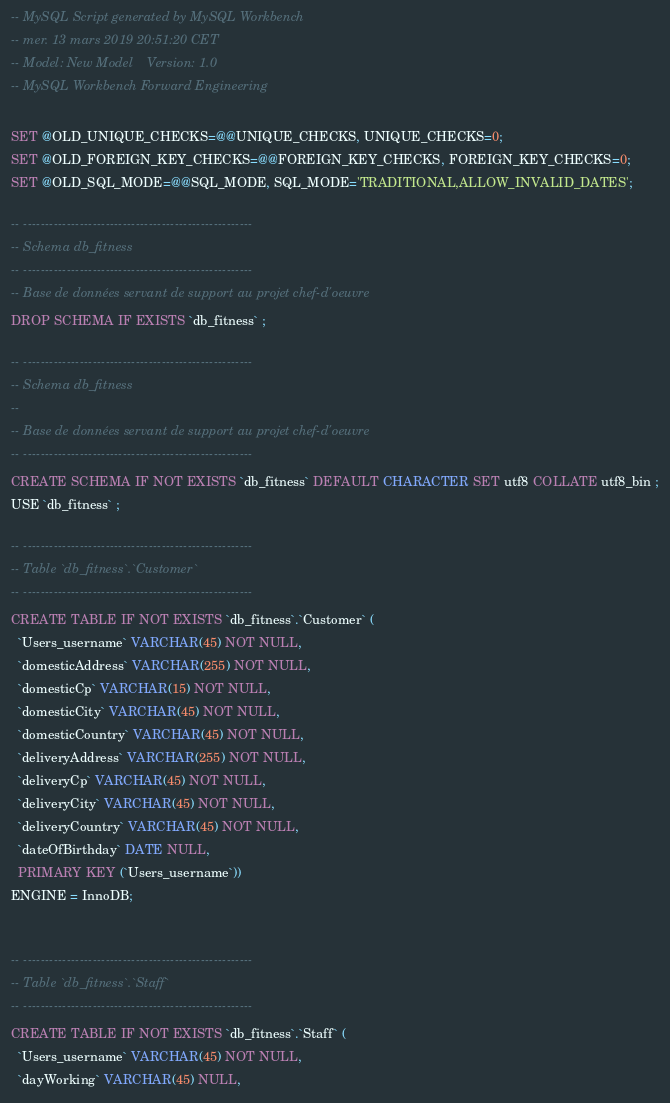Convert code to text. <code><loc_0><loc_0><loc_500><loc_500><_SQL_>-- MySQL Script generated by MySQL Workbench
-- mer. 13 mars 2019 20:51:20 CET
-- Model: New Model    Version: 1.0
-- MySQL Workbench Forward Engineering

SET @OLD_UNIQUE_CHECKS=@@UNIQUE_CHECKS, UNIQUE_CHECKS=0;
SET @OLD_FOREIGN_KEY_CHECKS=@@FOREIGN_KEY_CHECKS, FOREIGN_KEY_CHECKS=0;
SET @OLD_SQL_MODE=@@SQL_MODE, SQL_MODE='TRADITIONAL,ALLOW_INVALID_DATES';

-- -----------------------------------------------------
-- Schema db_fitness
-- -----------------------------------------------------
-- Base de données servant de support au projet chef-d'oeuvre
DROP SCHEMA IF EXISTS `db_fitness` ;

-- -----------------------------------------------------
-- Schema db_fitness
--
-- Base de données servant de support au projet chef-d'oeuvre
-- -----------------------------------------------------
CREATE SCHEMA IF NOT EXISTS `db_fitness` DEFAULT CHARACTER SET utf8 COLLATE utf8_bin ;
USE `db_fitness` ;

-- -----------------------------------------------------
-- Table `db_fitness`.`Customer`
-- -----------------------------------------------------
CREATE TABLE IF NOT EXISTS `db_fitness`.`Customer` (
  `Users_username` VARCHAR(45) NOT NULL,
  `domesticAddress` VARCHAR(255) NOT NULL,
  `domesticCp` VARCHAR(15) NOT NULL,
  `domesticCity` VARCHAR(45) NOT NULL,
  `domesticCountry` VARCHAR(45) NOT NULL,
  `deliveryAddress` VARCHAR(255) NOT NULL,
  `deliveryCp` VARCHAR(45) NOT NULL,
  `deliveryCity` VARCHAR(45) NOT NULL,
  `deliveryCountry` VARCHAR(45) NOT NULL,
  `dateOfBirthday` DATE NULL,
  PRIMARY KEY (`Users_username`))
ENGINE = InnoDB;


-- -----------------------------------------------------
-- Table `db_fitness`.`Staff`
-- -----------------------------------------------------
CREATE TABLE IF NOT EXISTS `db_fitness`.`Staff` (
  `Users_username` VARCHAR(45) NOT NULL,
  `dayWorking` VARCHAR(45) NULL,</code> 